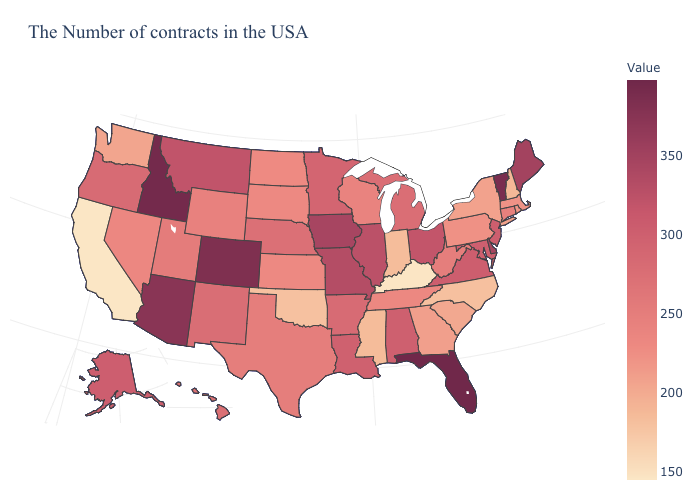Which states have the highest value in the USA?
Give a very brief answer. Florida. Among the states that border Minnesota , which have the highest value?
Be succinct. Iowa. Does Vermont have the highest value in the Northeast?
Quick response, please. Yes. 